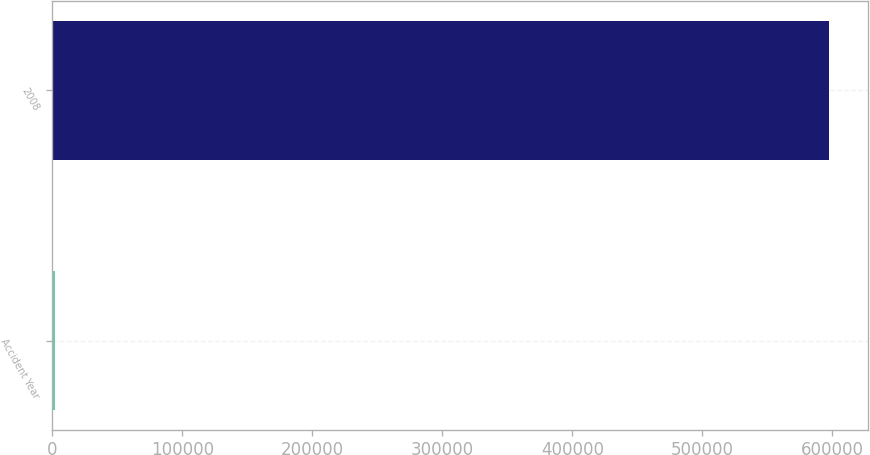Convert chart to OTSL. <chart><loc_0><loc_0><loc_500><loc_500><bar_chart><fcel>Accident Year<fcel>2008<nl><fcel>2017<fcel>597586<nl></chart> 